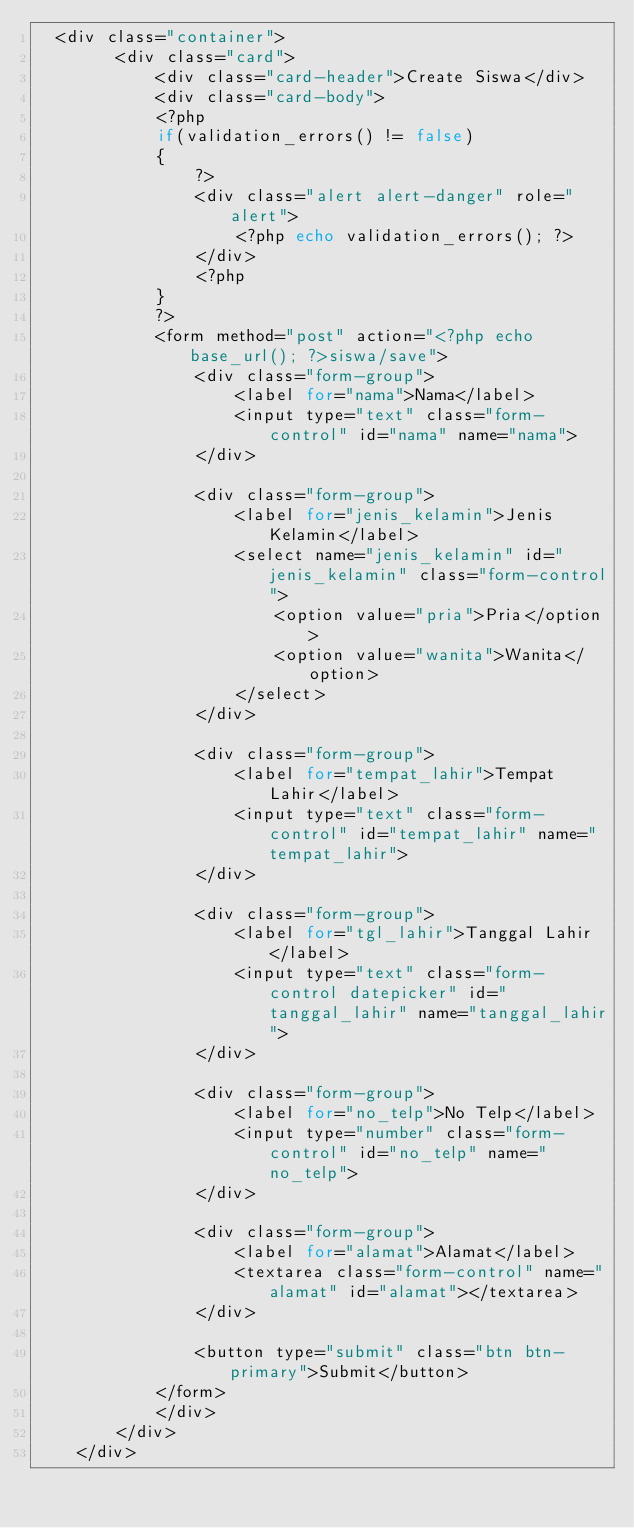Convert code to text. <code><loc_0><loc_0><loc_500><loc_500><_PHP_>  <div class="container">
		<div class="card">
			<div class="card-header">Create Siswa</div>
			<div class="card-body">
			<?php 
			if(validation_errors() != false)
			{
				?>
				<div class="alert alert-danger" role="alert">
					<?php echo validation_errors(); ?>
				</div>
				<?php
			}
			?>
			<form method="post" action="<?php echo base_url(); ?>siswa/save">
				<div class="form-group">
					<label for="nama">Nama</label>
					<input type="text" class="form-control" id="nama" name="nama">
				</div>

				<div class="form-group">
					<label for="jenis_kelamin">Jenis Kelamin</label>
					<select name="jenis_kelamin" id="jenis_kelamin" class="form-control">
						<option value="pria">Pria</option>
						<option value="wanita">Wanita</option>
					</select>
				</div>

				<div class="form-group">
					<label for="tempat_lahir">Tempat Lahir</label>
					<input type="text" class="form-control" id="tempat_lahir" name="tempat_lahir">
				</div>

				<div class="form-group">
					<label for="tgl_lahir">Tanggal Lahir</label>
					<input type="text" class="form-control datepicker" id="tanggal_lahir" name="tanggal_lahir">
				</div>

				<div class="form-group">
					<label for="no_telp">No Telp</label>
					<input type="number" class="form-control" id="no_telp" name="no_telp">
				</div>

				<div class="form-group">
					<label for="alamat">Alamat</label>
					<textarea class="form-control" name="alamat" id="alamat"></textarea>
				</div>

				<button type="submit" class="btn btn-primary">Submit</button>
			</form>
			</div>
		</div>
	</div>


</code> 